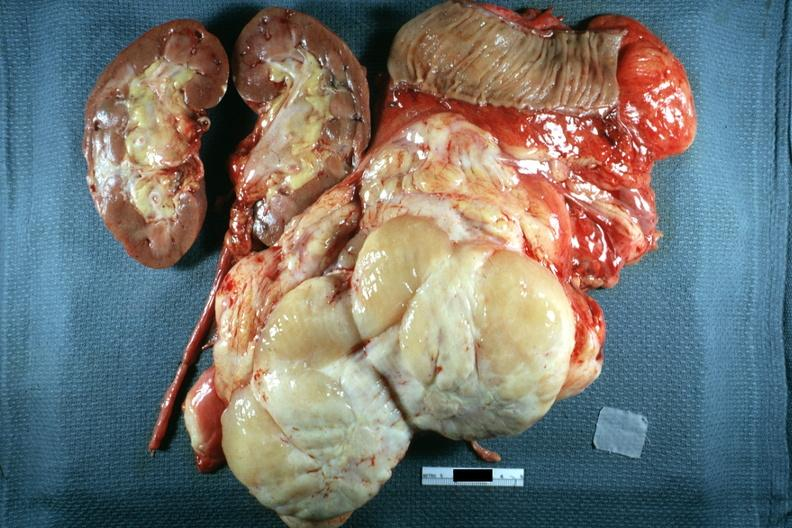s nodular tumor sectioned to show cut surface kidney portion of jejunum shown in this surgically resected specimen excellent?
Answer the question using a single word or phrase. Yes 